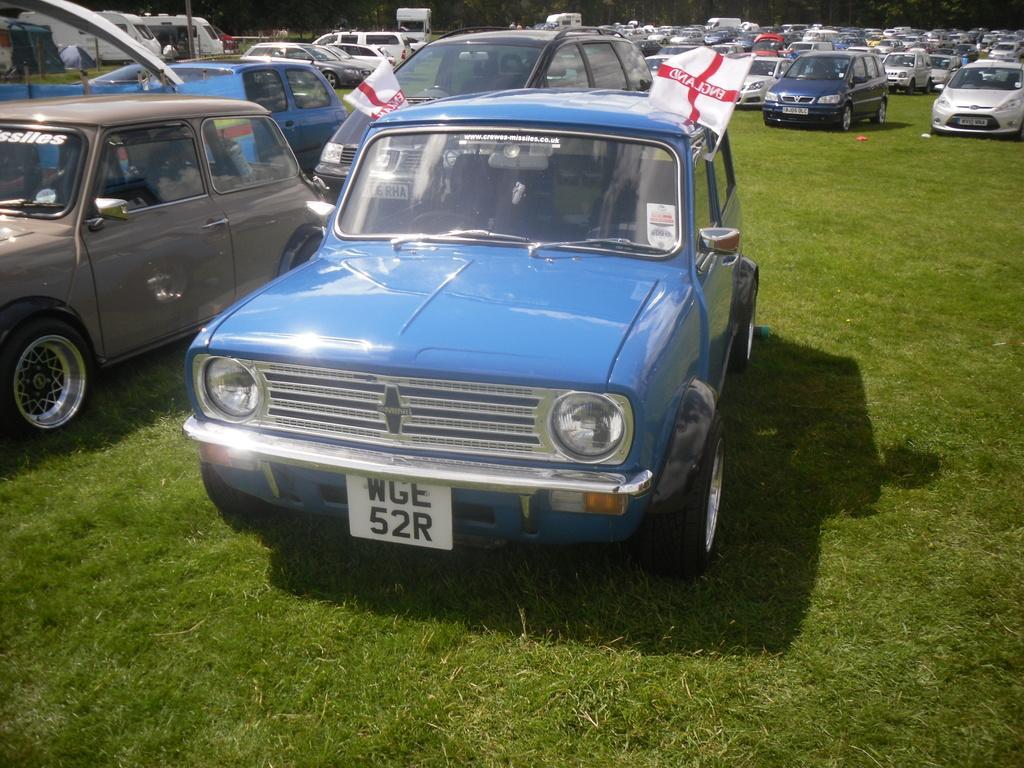Can you describe this image briefly? In front of the picture, we see the blue color car is parked. We see two flags in white and red color with some text written on it. Behind that, we see many cars parked on the grass. At the bottom, we see the grass. There are trees in the background. 